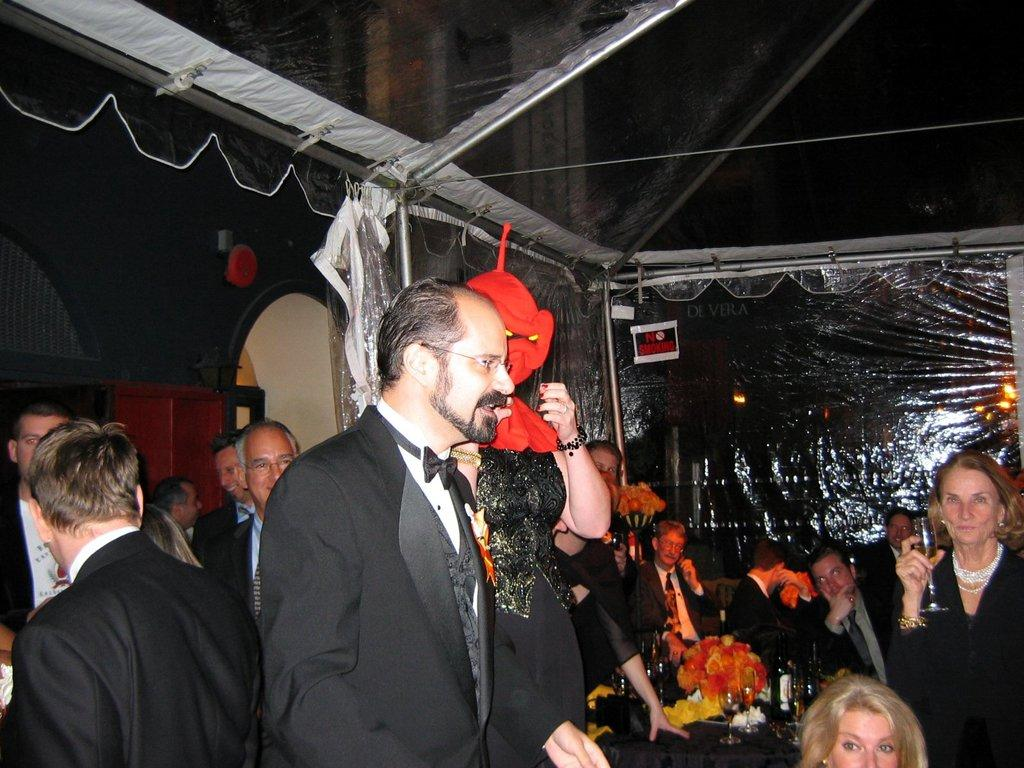How many people are in the image? There are people in the image, but the exact number is not specified. What can be observed about the people's clothing? The people are wearing different color dresses. What can be seen on the table in the image? There are objects on the table. What is visible in the background of the image? There is a building, a pole, and a cover in the background. What type of vein is visible in the image? There is no vein visible in the image. How does the acoustics of the room affect the people's conversation in the image? The facts provided do not mention anything about the acoustics of the room or the people's conversation, so it is impossible to answer this question. 